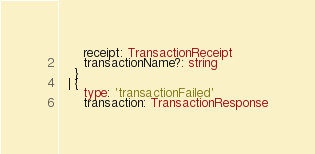<code> <loc_0><loc_0><loc_500><loc_500><_TypeScript_>      receipt: TransactionReceipt
      transactionName?: string
    }
  | {
      type: 'transactionFailed'
      transaction: TransactionResponse</code> 